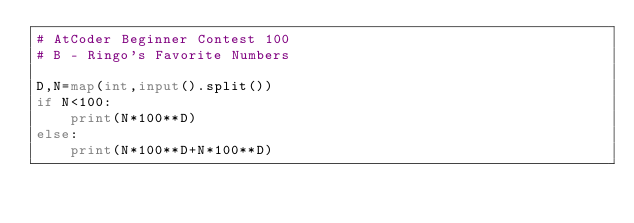<code> <loc_0><loc_0><loc_500><loc_500><_Python_># AtCoder Beginner Contest 100
# B - Ringo's Favorite Numbers

D,N=map(int,input().split())
if N<100:
    print(N*100**D)
else:
    print(N*100**D+N*100**D)</code> 